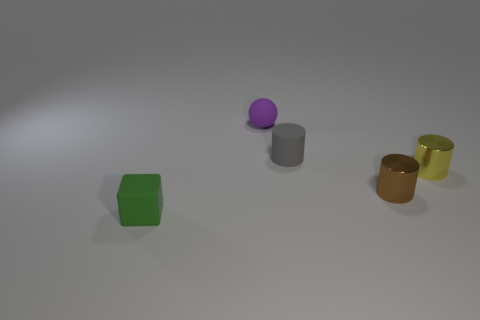Subtract all tiny metallic cylinders. How many cylinders are left? 1 Subtract 1 cylinders. How many cylinders are left? 2 Add 2 small cyan rubber cylinders. How many objects exist? 7 Subtract all red cylinders. Subtract all brown balls. How many cylinders are left? 3 Subtract all blocks. How many objects are left? 4 Add 3 small green cubes. How many small green cubes are left? 4 Add 2 small red rubber spheres. How many small red rubber spheres exist? 2 Subtract 0 blue spheres. How many objects are left? 5 Subtract all brown cylinders. Subtract all tiny metal cylinders. How many objects are left? 2 